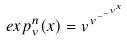Convert formula to latex. <formula><loc_0><loc_0><loc_500><loc_500>e x p _ { v } ^ { n } ( x ) = v ^ { v ^ { - ^ { - ^ { v ^ { x } } } } }</formula> 